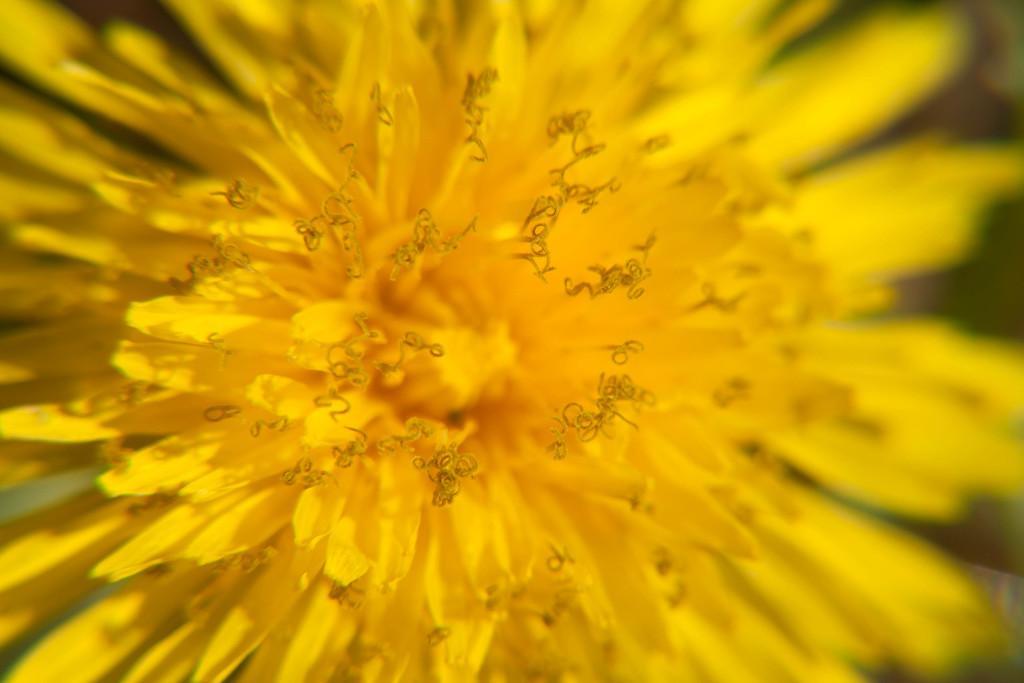In one or two sentences, can you explain what this image depicts? In this image I can see a yellow color flower. 